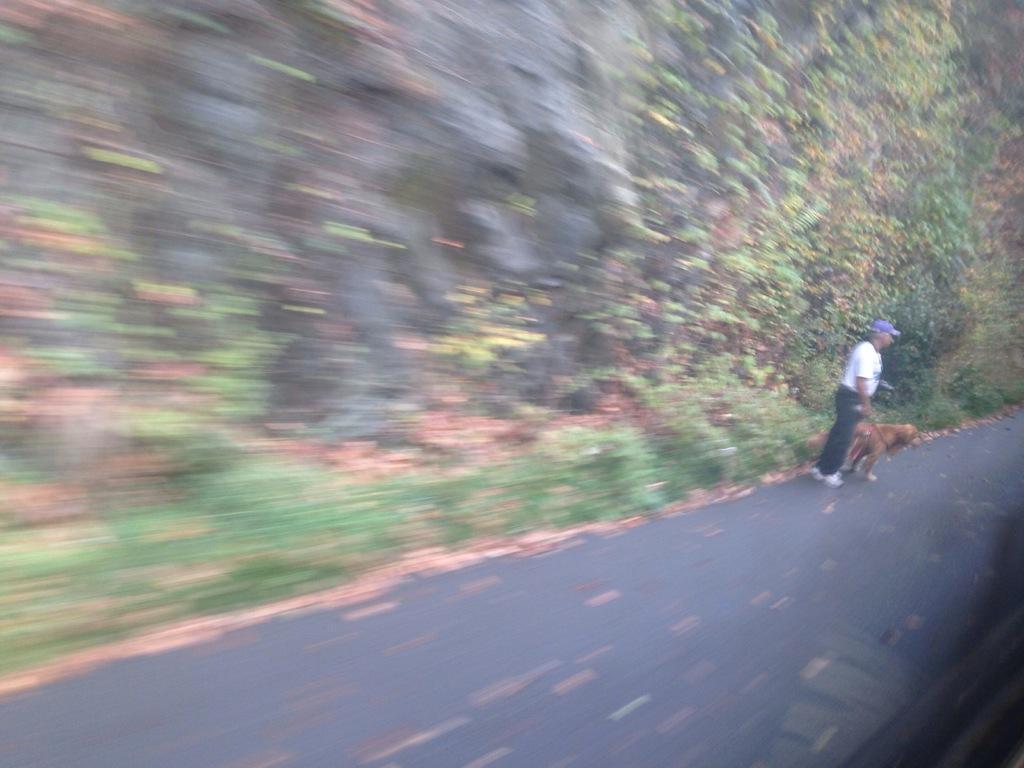Can you describe this image briefly? In this picture we can observe a person standing on the road, holding a belt of a dog in his hand. Beside the person there is a brown color dog standing on this road. We can observe some plants and trees. 